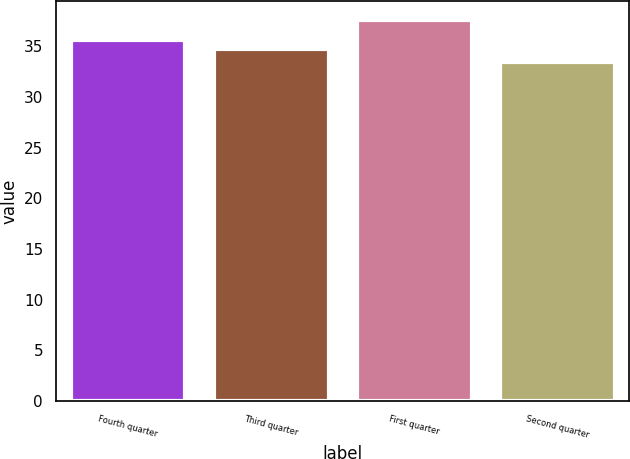Convert chart to OTSL. <chart><loc_0><loc_0><loc_500><loc_500><bar_chart><fcel>Fourth quarter<fcel>Third quarter<fcel>First quarter<fcel>Second quarter<nl><fcel>35.65<fcel>34.75<fcel>37.62<fcel>33.48<nl></chart> 